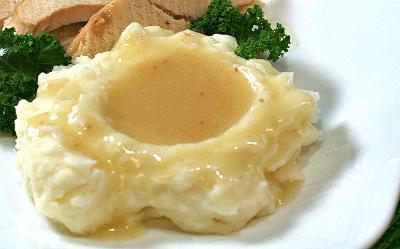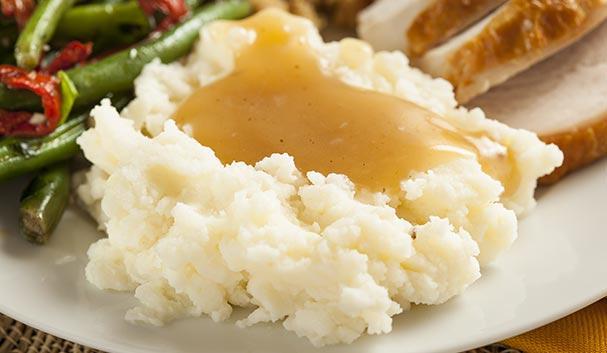The first image is the image on the left, the second image is the image on the right. Evaluate the accuracy of this statement regarding the images: "One serving of mashed potatoes is garnished with a pat of butter.". Is it true? Answer yes or no. No. 